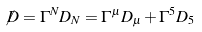<formula> <loc_0><loc_0><loc_500><loc_500>\not { D } = \Gamma ^ { N } D _ { N } = \Gamma ^ { \mu } D _ { \mu } + \Gamma ^ { 5 } D _ { 5 }</formula> 